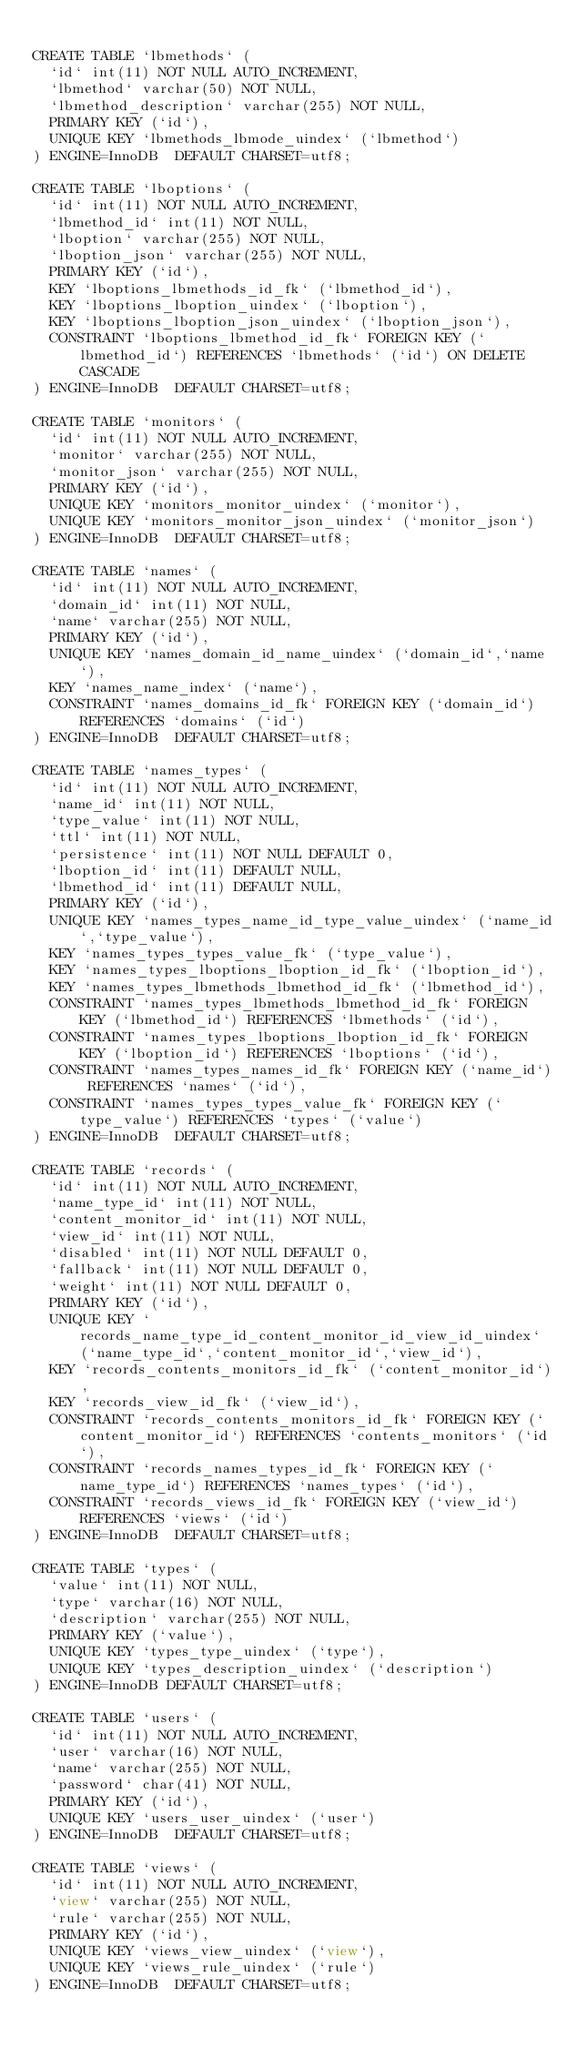Convert code to text. <code><loc_0><loc_0><loc_500><loc_500><_SQL_>
CREATE TABLE `lbmethods` (
  `id` int(11) NOT NULL AUTO_INCREMENT,
  `lbmethod` varchar(50) NOT NULL,
  `lbmethod_description` varchar(255) NOT NULL,
  PRIMARY KEY (`id`),
  UNIQUE KEY `lbmethods_lbmode_uindex` (`lbmethod`)
) ENGINE=InnoDB  DEFAULT CHARSET=utf8;

CREATE TABLE `lboptions` (
  `id` int(11) NOT NULL AUTO_INCREMENT,
  `lbmethod_id` int(11) NOT NULL,
  `lboption` varchar(255) NOT NULL,
  `lboption_json` varchar(255) NOT NULL,
  PRIMARY KEY (`id`),
  KEY `lboptions_lbmethods_id_fk` (`lbmethod_id`),
  KEY `lboptions_lboption_uindex` (`lboption`),
  KEY `lboptions_lboption_json_uindex` (`lboption_json`),
  CONSTRAINT `lboptions_lbmethod_id_fk` FOREIGN KEY (`lbmethod_id`) REFERENCES `lbmethods` (`id`) ON DELETE CASCADE
) ENGINE=InnoDB  DEFAULT CHARSET=utf8;

CREATE TABLE `monitors` (
  `id` int(11) NOT NULL AUTO_INCREMENT,
  `monitor` varchar(255) NOT NULL,
  `monitor_json` varchar(255) NOT NULL,
  PRIMARY KEY (`id`),
  UNIQUE KEY `monitors_monitor_uindex` (`monitor`),
  UNIQUE KEY `monitors_monitor_json_uindex` (`monitor_json`)
) ENGINE=InnoDB  DEFAULT CHARSET=utf8;

CREATE TABLE `names` (
  `id` int(11) NOT NULL AUTO_INCREMENT,
  `domain_id` int(11) NOT NULL,
  `name` varchar(255) NOT NULL,
  PRIMARY KEY (`id`),
  UNIQUE KEY `names_domain_id_name_uindex` (`domain_id`,`name`),
  KEY `names_name_index` (`name`),
  CONSTRAINT `names_domains_id_fk` FOREIGN KEY (`domain_id`) REFERENCES `domains` (`id`)
) ENGINE=InnoDB  DEFAULT CHARSET=utf8;

CREATE TABLE `names_types` (
  `id` int(11) NOT NULL AUTO_INCREMENT,
  `name_id` int(11) NOT NULL,
  `type_value` int(11) NOT NULL,
  `ttl` int(11) NOT NULL,
  `persistence` int(11) NOT NULL DEFAULT 0,
  `lboption_id` int(11) DEFAULT NULL,
  `lbmethod_id` int(11) DEFAULT NULL,
  PRIMARY KEY (`id`),
  UNIQUE KEY `names_types_name_id_type_value_uindex` (`name_id`,`type_value`),
  KEY `names_types_types_value_fk` (`type_value`),
  KEY `names_types_lboptions_lboption_id_fk` (`lboption_id`),
  KEY `names_types_lbmethods_lbmethod_id_fk` (`lbmethod_id`),
  CONSTRAINT `names_types_lbmethods_lbmethod_id_fk` FOREIGN KEY (`lbmethod_id`) REFERENCES `lbmethods` (`id`),
  CONSTRAINT `names_types_lboptions_lboption_id_fk` FOREIGN KEY (`lboption_id`) REFERENCES `lboptions` (`id`),
  CONSTRAINT `names_types_names_id_fk` FOREIGN KEY (`name_id`) REFERENCES `names` (`id`),
  CONSTRAINT `names_types_types_value_fk` FOREIGN KEY (`type_value`) REFERENCES `types` (`value`)
) ENGINE=InnoDB  DEFAULT CHARSET=utf8;

CREATE TABLE `records` (
  `id` int(11) NOT NULL AUTO_INCREMENT,
  `name_type_id` int(11) NOT NULL,
  `content_monitor_id` int(11) NOT NULL,
  `view_id` int(11) NOT NULL,
  `disabled` int(11) NOT NULL DEFAULT 0,
  `fallback` int(11) NOT NULL DEFAULT 0,
  `weight` int(11) NOT NULL DEFAULT 0,
  PRIMARY KEY (`id`),
  UNIQUE KEY `records_name_type_id_content_monitor_id_view_id_uindex` (`name_type_id`,`content_monitor_id`,`view_id`),
  KEY `records_contents_monitors_id_fk` (`content_monitor_id`),
  KEY `records_view_id_fk` (`view_id`),
  CONSTRAINT `records_contents_monitors_id_fk` FOREIGN KEY (`content_monitor_id`) REFERENCES `contents_monitors` (`id`),
  CONSTRAINT `records_names_types_id_fk` FOREIGN KEY (`name_type_id`) REFERENCES `names_types` (`id`),
  CONSTRAINT `records_views_id_fk` FOREIGN KEY (`view_id`) REFERENCES `views` (`id`)
) ENGINE=InnoDB  DEFAULT CHARSET=utf8;

CREATE TABLE `types` (
  `value` int(11) NOT NULL,
  `type` varchar(16) NOT NULL,
  `description` varchar(255) NOT NULL,
  PRIMARY KEY (`value`),
  UNIQUE KEY `types_type_uindex` (`type`),
  UNIQUE KEY `types_description_uindex` (`description`)
) ENGINE=InnoDB DEFAULT CHARSET=utf8;

CREATE TABLE `users` (
  `id` int(11) NOT NULL AUTO_INCREMENT,
  `user` varchar(16) NOT NULL,
  `name` varchar(255) NOT NULL,
  `password` char(41) NOT NULL,
  PRIMARY KEY (`id`),
  UNIQUE KEY `users_user_uindex` (`user`)
) ENGINE=InnoDB  DEFAULT CHARSET=utf8;

CREATE TABLE `views` (
  `id` int(11) NOT NULL AUTO_INCREMENT,
  `view` varchar(255) NOT NULL,
  `rule` varchar(255) NOT NULL,
  PRIMARY KEY (`id`),
  UNIQUE KEY `views_view_uindex` (`view`),
  UNIQUE KEY `views_rule_uindex` (`rule`)
) ENGINE=InnoDB  DEFAULT CHARSET=utf8;

</code> 